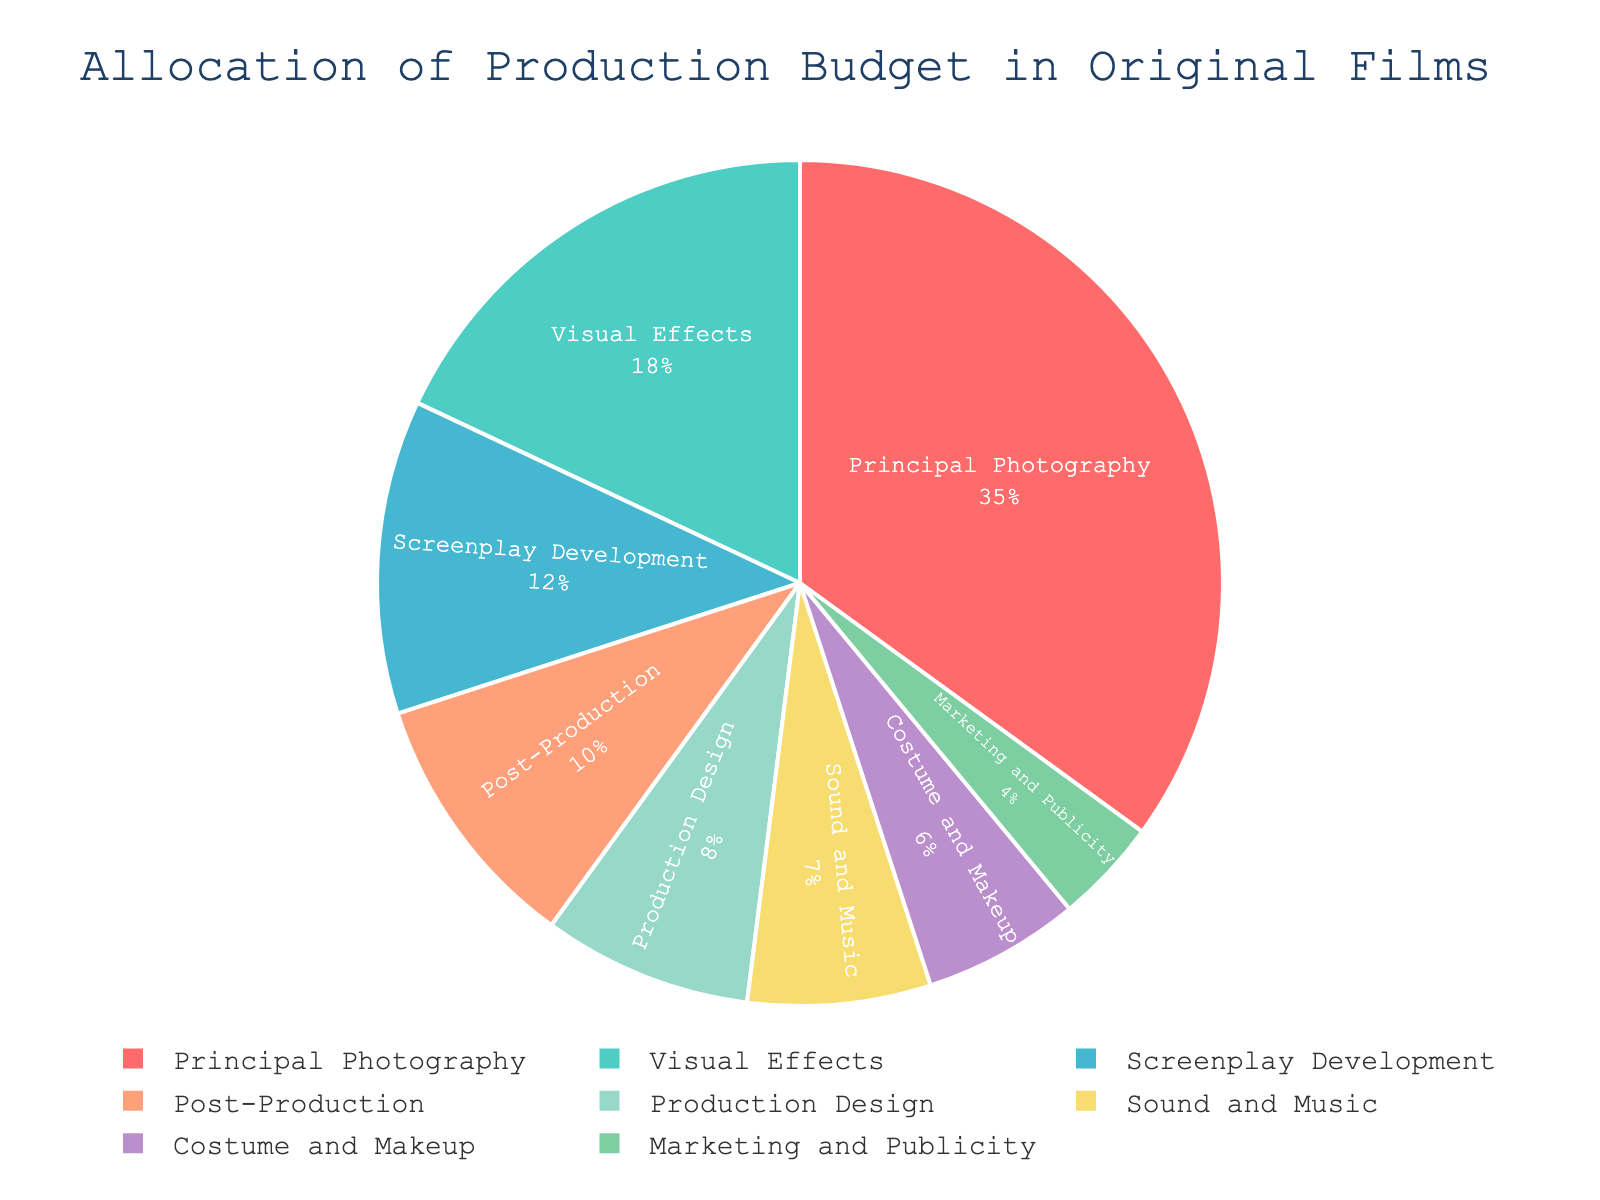Which department receives the largest portion of the production budget? Examine the pie chart and identify the slice with the largest percentage. The largest slice corresponds to Principal Photography at 35%.
Answer: Principal Photography Which department receives the smallest portion of the production budget? Look for the slice with the smallest percentage in the pie chart. Marketing and Publicity has the smallest slice at 4%.
Answer: Marketing and Publicity What is the combined budget percentage for Visual Effects and Post-Production? Add the percentages for Visual Effects and Post-Production: 18% + 10% = 28%.
Answer: 28% How much greater is the percentage allocation for Principal Photography compared to Sound and Music? Subtract the percentage for Sound and Music from the percentage for Principal Photography: 35% - 7% = 28%.
Answer: 28% What is the difference in budget allocation between Costume and Makeup and Production Design? Subtract the percentage of Budget for Costume and Makeup from Production Design: 8% - 6% = 2%.
Answer: 2% What is the total percentage allocated to Screenplay Development, Sound and Music, and Costume and Makeup? Add the percentages for Screenplay Development, Sound and Music, and Costume and Makeup: 12% + 7% + 6% = 25%.
Answer: 25% Is the allocation for Post-Production greater than that for Marketing and Publicity? Compare the percentages for Post-Production and Marketing and Publicity. Post-Production is 10%, and Marketing and Publicity is 4%; therefore, 10% is greater than 4%.
Answer: Yes Which department with an allocation of less than 10% has the highest budget percentage? Among the departments with allocations less than 10%, Production Design has the highest budget percentage at 8%.
Answer: Production Design Are there more departments with a budget allocation above 10% or below 10%? Identify and count the departments above and below 10%. Above 10%: Screenplay Development, Principal Photography, and Visual Effects (3). Below 10%: Production Design, Costume and Makeup, Sound and Music, Post-Production, and Marketing and Publicity (5).
Answer: Below 10% What is the average percentage allocation for Screenplay Development, Principal Photography, and Visual Effects? Calculate the average by summing the percentages and dividing by the number of departments: (12% + 35% + 18%) / 3 = 65% / 3 = 21.67%.
Answer: 21.67% 